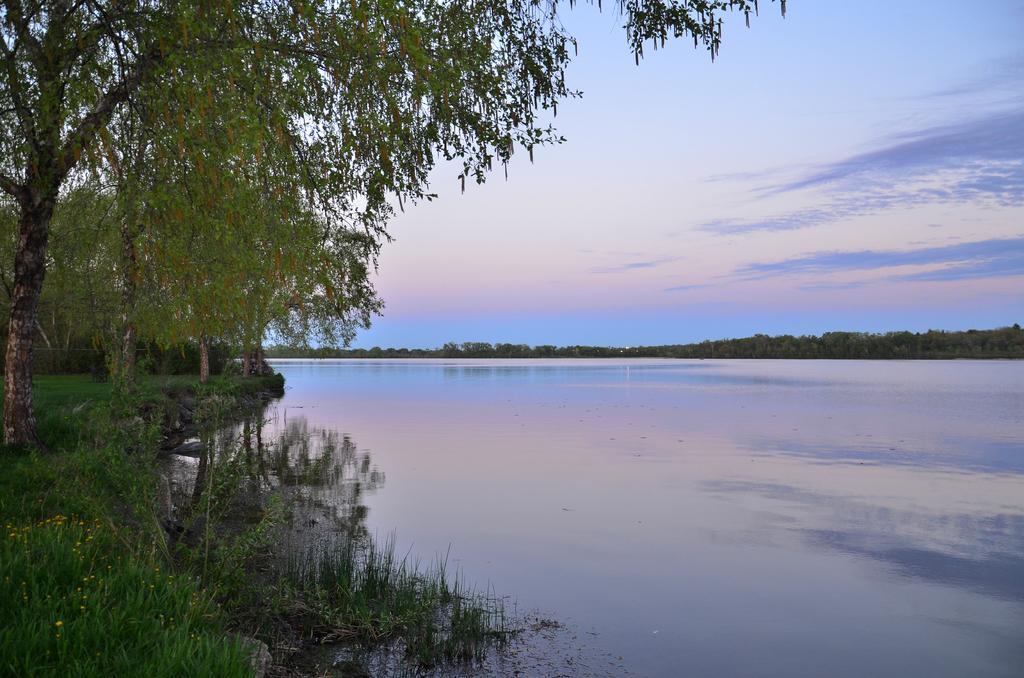How would you summarize this image in a sentence or two? In this picture I can see water, trees and grass. In the background I can see the sky. 